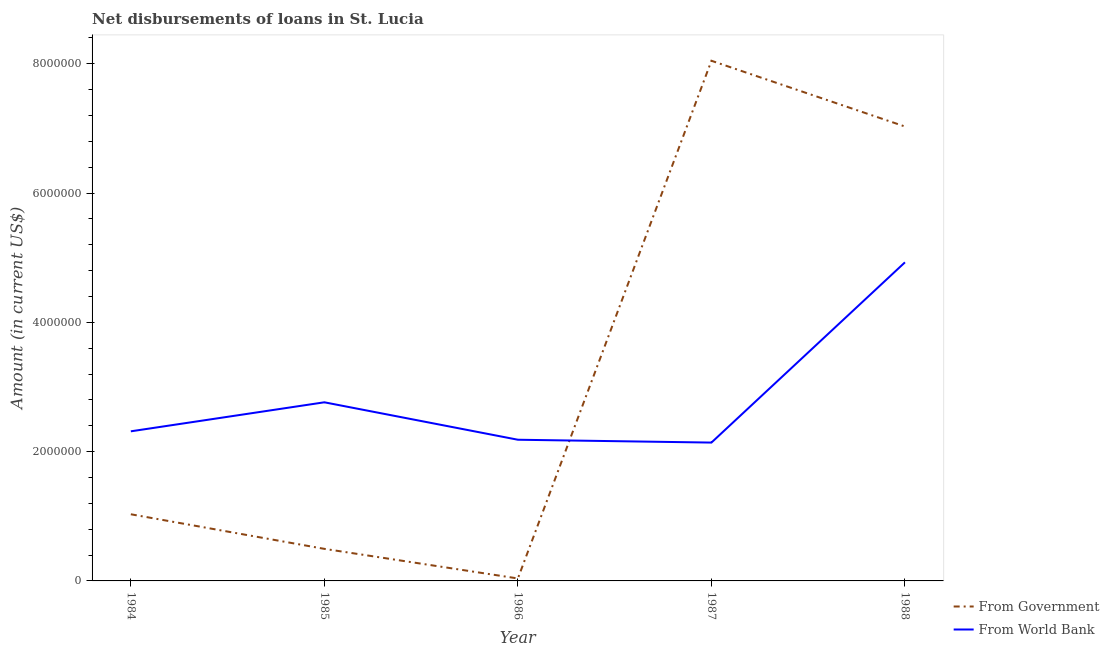How many different coloured lines are there?
Your response must be concise. 2. Does the line corresponding to net disbursements of loan from government intersect with the line corresponding to net disbursements of loan from world bank?
Your answer should be compact. Yes. What is the net disbursements of loan from world bank in 1984?
Give a very brief answer. 2.31e+06. Across all years, what is the maximum net disbursements of loan from world bank?
Ensure brevity in your answer.  4.93e+06. Across all years, what is the minimum net disbursements of loan from world bank?
Offer a very short reply. 2.14e+06. In which year was the net disbursements of loan from world bank minimum?
Give a very brief answer. 1987. What is the total net disbursements of loan from government in the graph?
Ensure brevity in your answer.  1.66e+07. What is the difference between the net disbursements of loan from government in 1984 and that in 1986?
Your answer should be very brief. 9.93e+05. What is the difference between the net disbursements of loan from government in 1988 and the net disbursements of loan from world bank in 1985?
Your response must be concise. 4.27e+06. What is the average net disbursements of loan from government per year?
Offer a terse response. 3.33e+06. In the year 1985, what is the difference between the net disbursements of loan from world bank and net disbursements of loan from government?
Your response must be concise. 2.27e+06. In how many years, is the net disbursements of loan from world bank greater than 6800000 US$?
Give a very brief answer. 0. What is the ratio of the net disbursements of loan from world bank in 1984 to that in 1985?
Ensure brevity in your answer.  0.84. Is the net disbursements of loan from world bank in 1986 less than that in 1987?
Keep it short and to the point. No. What is the difference between the highest and the second highest net disbursements of loan from world bank?
Offer a terse response. 2.16e+06. What is the difference between the highest and the lowest net disbursements of loan from government?
Provide a succinct answer. 8.01e+06. Is the sum of the net disbursements of loan from government in 1985 and 1988 greater than the maximum net disbursements of loan from world bank across all years?
Provide a short and direct response. Yes. Is the net disbursements of loan from world bank strictly greater than the net disbursements of loan from government over the years?
Offer a terse response. No. Is the net disbursements of loan from government strictly less than the net disbursements of loan from world bank over the years?
Offer a very short reply. No. How many years are there in the graph?
Provide a short and direct response. 5. What is the difference between two consecutive major ticks on the Y-axis?
Offer a very short reply. 2.00e+06. How are the legend labels stacked?
Ensure brevity in your answer.  Vertical. What is the title of the graph?
Your response must be concise. Net disbursements of loans in St. Lucia. Does "Automatic Teller Machines" appear as one of the legend labels in the graph?
Make the answer very short. No. What is the label or title of the Y-axis?
Keep it short and to the point. Amount (in current US$). What is the Amount (in current US$) in From Government in 1984?
Your answer should be very brief. 1.03e+06. What is the Amount (in current US$) of From World Bank in 1984?
Ensure brevity in your answer.  2.31e+06. What is the Amount (in current US$) of From Government in 1985?
Provide a succinct answer. 4.96e+05. What is the Amount (in current US$) in From World Bank in 1985?
Keep it short and to the point. 2.76e+06. What is the Amount (in current US$) in From Government in 1986?
Your response must be concise. 3.80e+04. What is the Amount (in current US$) in From World Bank in 1986?
Keep it short and to the point. 2.18e+06. What is the Amount (in current US$) in From Government in 1987?
Provide a succinct answer. 8.05e+06. What is the Amount (in current US$) of From World Bank in 1987?
Your answer should be compact. 2.14e+06. What is the Amount (in current US$) in From Government in 1988?
Ensure brevity in your answer.  7.03e+06. What is the Amount (in current US$) of From World Bank in 1988?
Ensure brevity in your answer.  4.93e+06. Across all years, what is the maximum Amount (in current US$) of From Government?
Ensure brevity in your answer.  8.05e+06. Across all years, what is the maximum Amount (in current US$) of From World Bank?
Provide a succinct answer. 4.93e+06. Across all years, what is the minimum Amount (in current US$) in From Government?
Give a very brief answer. 3.80e+04. Across all years, what is the minimum Amount (in current US$) of From World Bank?
Ensure brevity in your answer.  2.14e+06. What is the total Amount (in current US$) in From Government in the graph?
Ensure brevity in your answer.  1.66e+07. What is the total Amount (in current US$) of From World Bank in the graph?
Give a very brief answer. 1.43e+07. What is the difference between the Amount (in current US$) of From Government in 1984 and that in 1985?
Your answer should be very brief. 5.35e+05. What is the difference between the Amount (in current US$) of From World Bank in 1984 and that in 1985?
Your answer should be compact. -4.49e+05. What is the difference between the Amount (in current US$) in From Government in 1984 and that in 1986?
Ensure brevity in your answer.  9.93e+05. What is the difference between the Amount (in current US$) in From Government in 1984 and that in 1987?
Your answer should be compact. -7.02e+06. What is the difference between the Amount (in current US$) of From World Bank in 1984 and that in 1987?
Your answer should be very brief. 1.74e+05. What is the difference between the Amount (in current US$) in From Government in 1984 and that in 1988?
Offer a terse response. -6.00e+06. What is the difference between the Amount (in current US$) in From World Bank in 1984 and that in 1988?
Provide a short and direct response. -2.61e+06. What is the difference between the Amount (in current US$) in From Government in 1985 and that in 1986?
Provide a short and direct response. 4.58e+05. What is the difference between the Amount (in current US$) of From World Bank in 1985 and that in 1986?
Offer a very short reply. 5.79e+05. What is the difference between the Amount (in current US$) of From Government in 1985 and that in 1987?
Offer a very short reply. -7.55e+06. What is the difference between the Amount (in current US$) in From World Bank in 1985 and that in 1987?
Give a very brief answer. 6.23e+05. What is the difference between the Amount (in current US$) in From Government in 1985 and that in 1988?
Your answer should be very brief. -6.53e+06. What is the difference between the Amount (in current US$) of From World Bank in 1985 and that in 1988?
Make the answer very short. -2.16e+06. What is the difference between the Amount (in current US$) of From Government in 1986 and that in 1987?
Give a very brief answer. -8.01e+06. What is the difference between the Amount (in current US$) of From World Bank in 1986 and that in 1987?
Make the answer very short. 4.40e+04. What is the difference between the Amount (in current US$) in From Government in 1986 and that in 1988?
Your answer should be very brief. -6.99e+06. What is the difference between the Amount (in current US$) in From World Bank in 1986 and that in 1988?
Offer a very short reply. -2.74e+06. What is the difference between the Amount (in current US$) of From Government in 1987 and that in 1988?
Offer a very short reply. 1.02e+06. What is the difference between the Amount (in current US$) of From World Bank in 1987 and that in 1988?
Offer a terse response. -2.79e+06. What is the difference between the Amount (in current US$) in From Government in 1984 and the Amount (in current US$) in From World Bank in 1985?
Your answer should be compact. -1.73e+06. What is the difference between the Amount (in current US$) in From Government in 1984 and the Amount (in current US$) in From World Bank in 1986?
Make the answer very short. -1.15e+06. What is the difference between the Amount (in current US$) in From Government in 1984 and the Amount (in current US$) in From World Bank in 1987?
Give a very brief answer. -1.11e+06. What is the difference between the Amount (in current US$) of From Government in 1984 and the Amount (in current US$) of From World Bank in 1988?
Your answer should be compact. -3.90e+06. What is the difference between the Amount (in current US$) of From Government in 1985 and the Amount (in current US$) of From World Bank in 1986?
Make the answer very short. -1.69e+06. What is the difference between the Amount (in current US$) in From Government in 1985 and the Amount (in current US$) in From World Bank in 1987?
Your answer should be very brief. -1.64e+06. What is the difference between the Amount (in current US$) in From Government in 1985 and the Amount (in current US$) in From World Bank in 1988?
Ensure brevity in your answer.  -4.43e+06. What is the difference between the Amount (in current US$) in From Government in 1986 and the Amount (in current US$) in From World Bank in 1987?
Offer a terse response. -2.10e+06. What is the difference between the Amount (in current US$) of From Government in 1986 and the Amount (in current US$) of From World Bank in 1988?
Your answer should be very brief. -4.89e+06. What is the difference between the Amount (in current US$) in From Government in 1987 and the Amount (in current US$) in From World Bank in 1988?
Ensure brevity in your answer.  3.12e+06. What is the average Amount (in current US$) of From Government per year?
Your answer should be compact. 3.33e+06. What is the average Amount (in current US$) of From World Bank per year?
Provide a succinct answer. 2.87e+06. In the year 1984, what is the difference between the Amount (in current US$) of From Government and Amount (in current US$) of From World Bank?
Make the answer very short. -1.28e+06. In the year 1985, what is the difference between the Amount (in current US$) of From Government and Amount (in current US$) of From World Bank?
Provide a succinct answer. -2.27e+06. In the year 1986, what is the difference between the Amount (in current US$) of From Government and Amount (in current US$) of From World Bank?
Make the answer very short. -2.15e+06. In the year 1987, what is the difference between the Amount (in current US$) in From Government and Amount (in current US$) in From World Bank?
Make the answer very short. 5.91e+06. In the year 1988, what is the difference between the Amount (in current US$) of From Government and Amount (in current US$) of From World Bank?
Offer a very short reply. 2.10e+06. What is the ratio of the Amount (in current US$) in From Government in 1984 to that in 1985?
Make the answer very short. 2.08. What is the ratio of the Amount (in current US$) of From World Bank in 1984 to that in 1985?
Your answer should be very brief. 0.84. What is the ratio of the Amount (in current US$) in From Government in 1984 to that in 1986?
Make the answer very short. 27.13. What is the ratio of the Amount (in current US$) in From World Bank in 1984 to that in 1986?
Provide a short and direct response. 1.06. What is the ratio of the Amount (in current US$) in From Government in 1984 to that in 1987?
Offer a very short reply. 0.13. What is the ratio of the Amount (in current US$) of From World Bank in 1984 to that in 1987?
Your answer should be very brief. 1.08. What is the ratio of the Amount (in current US$) of From Government in 1984 to that in 1988?
Provide a short and direct response. 0.15. What is the ratio of the Amount (in current US$) in From World Bank in 1984 to that in 1988?
Your answer should be compact. 0.47. What is the ratio of the Amount (in current US$) in From Government in 1985 to that in 1986?
Make the answer very short. 13.05. What is the ratio of the Amount (in current US$) in From World Bank in 1985 to that in 1986?
Your answer should be compact. 1.27. What is the ratio of the Amount (in current US$) of From Government in 1985 to that in 1987?
Make the answer very short. 0.06. What is the ratio of the Amount (in current US$) of From World Bank in 1985 to that in 1987?
Provide a short and direct response. 1.29. What is the ratio of the Amount (in current US$) in From Government in 1985 to that in 1988?
Ensure brevity in your answer.  0.07. What is the ratio of the Amount (in current US$) of From World Bank in 1985 to that in 1988?
Keep it short and to the point. 0.56. What is the ratio of the Amount (in current US$) in From Government in 1986 to that in 1987?
Give a very brief answer. 0. What is the ratio of the Amount (in current US$) of From World Bank in 1986 to that in 1987?
Ensure brevity in your answer.  1.02. What is the ratio of the Amount (in current US$) of From Government in 1986 to that in 1988?
Keep it short and to the point. 0.01. What is the ratio of the Amount (in current US$) in From World Bank in 1986 to that in 1988?
Offer a terse response. 0.44. What is the ratio of the Amount (in current US$) of From Government in 1987 to that in 1988?
Make the answer very short. 1.14. What is the ratio of the Amount (in current US$) of From World Bank in 1987 to that in 1988?
Give a very brief answer. 0.43. What is the difference between the highest and the second highest Amount (in current US$) of From Government?
Provide a short and direct response. 1.02e+06. What is the difference between the highest and the second highest Amount (in current US$) in From World Bank?
Provide a succinct answer. 2.16e+06. What is the difference between the highest and the lowest Amount (in current US$) of From Government?
Your answer should be very brief. 8.01e+06. What is the difference between the highest and the lowest Amount (in current US$) in From World Bank?
Your answer should be compact. 2.79e+06. 